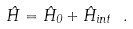<formula> <loc_0><loc_0><loc_500><loc_500>\hat { H } = \hat { H } _ { 0 } + \hat { H } _ { i n t } \ .</formula> 